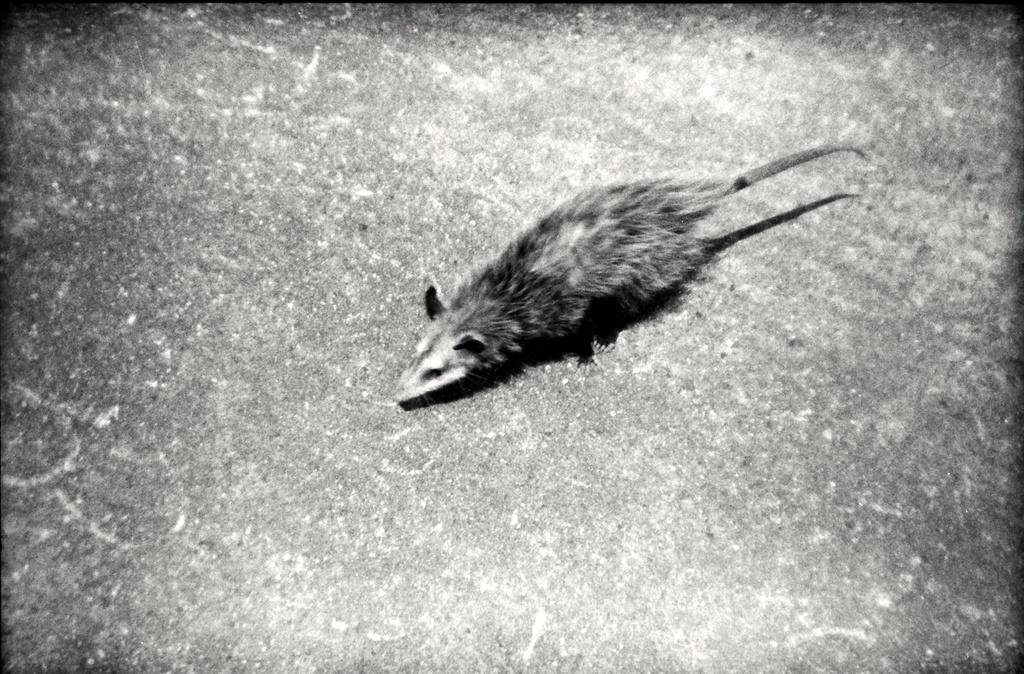What is on the floor in the image? There is a mouse on the floor in the image. What type of event is happening with the apple in the image? There is no apple present in the image, so it is not possible to answer that question. 